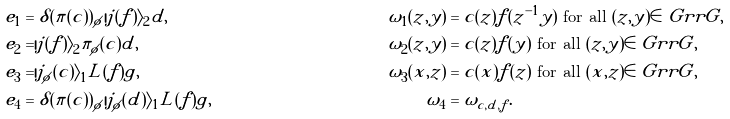<formula> <loc_0><loc_0><loc_500><loc_500>e _ { 1 } & = \delta ( \pi ( c ) ) _ { \phi } | j ( f ) \rangle _ { 2 } d , & \omega _ { 1 } ( z , y ) & = c ( z ) f ( z ^ { - 1 } y ) \text { for all } ( z , y ) \in \ G r r G , \\ e _ { 2 } & = | j ( f ) \rangle _ { 2 } \pi _ { \phi } ( c ) d , & \omega _ { 2 } ( z , y ) & = c ( z ) f ( y ) \text { for all } ( z , y ) \in \ G r r G , \\ e _ { 3 } & = | j _ { \phi } ( c ) \rangle _ { 1 } L ( f ) g , & \omega _ { 3 } ( x , z ) & = c ( x ) f ( z ) \text { for all } ( x , z ) \in \ G r r G , \\ e _ { 4 } & = \delta ( \pi ( c ) ) _ { \phi } | j _ { \phi } ( d ) \rangle _ { 1 } L ( f ) g , & \omega _ { 4 } & = \omega _ { c , d , f } .</formula> 